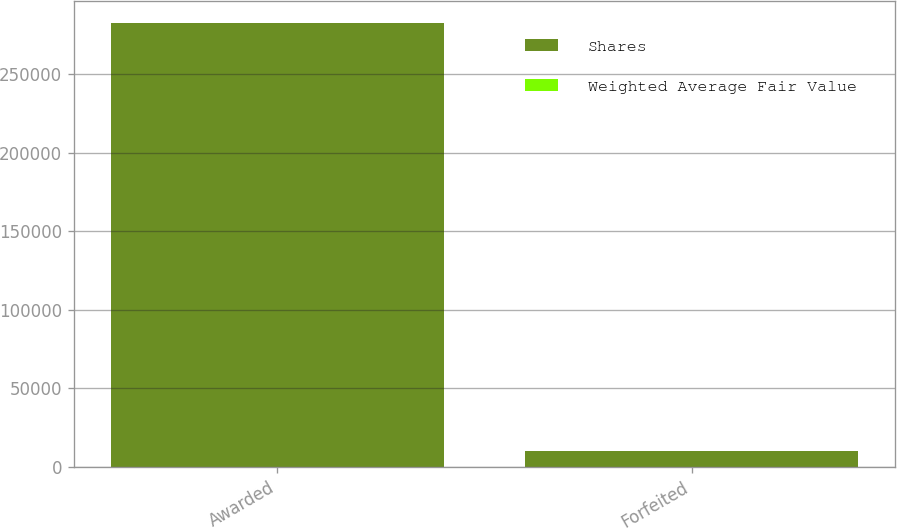Convert chart. <chart><loc_0><loc_0><loc_500><loc_500><stacked_bar_chart><ecel><fcel>Awarded<fcel>Forfeited<nl><fcel>Shares<fcel>282423<fcel>10000<nl><fcel>Weighted Average Fair Value<fcel>67.11<fcel>43.41<nl></chart> 